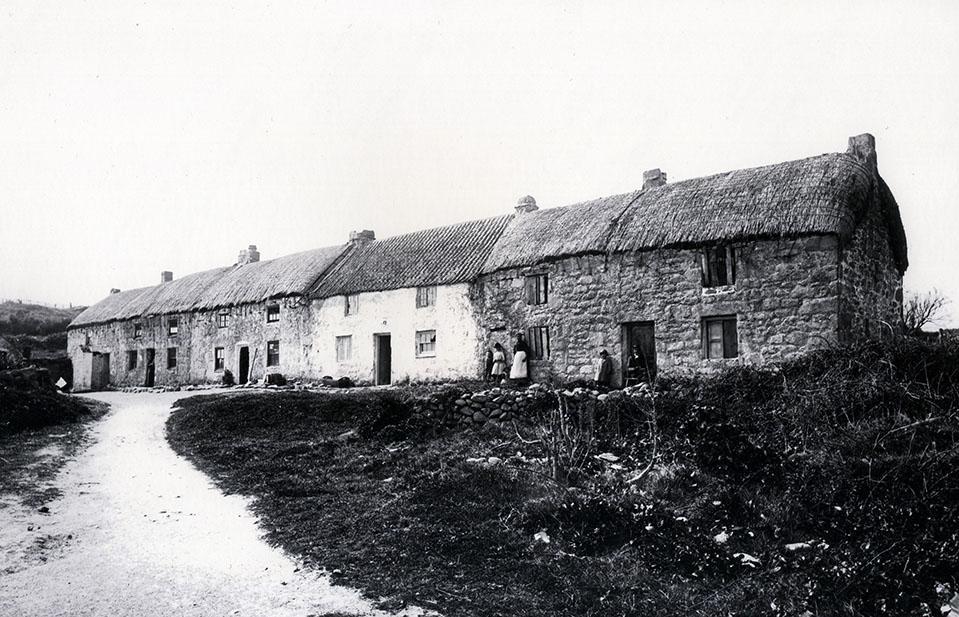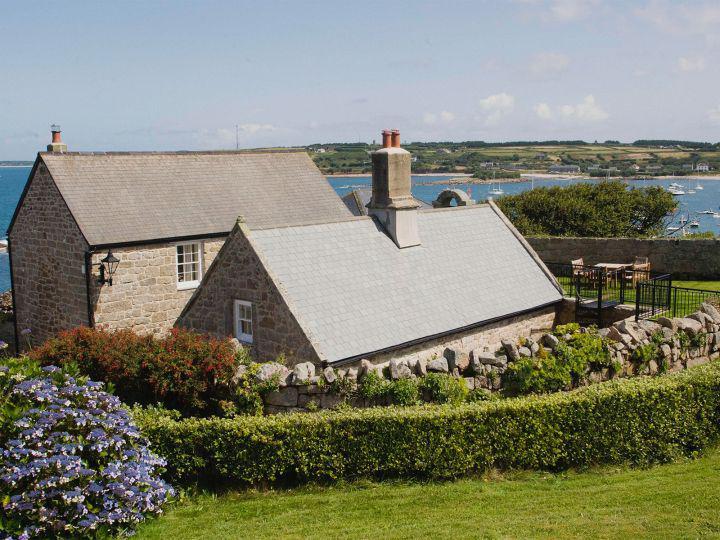The first image is the image on the left, the second image is the image on the right. Examine the images to the left and right. Is the description "One image shows buildings with smooth, flat, straight roofs, and the the other image shows rustic-looking stone buildings with roofs that are textured and uneven-looking." accurate? Answer yes or no. Yes. 